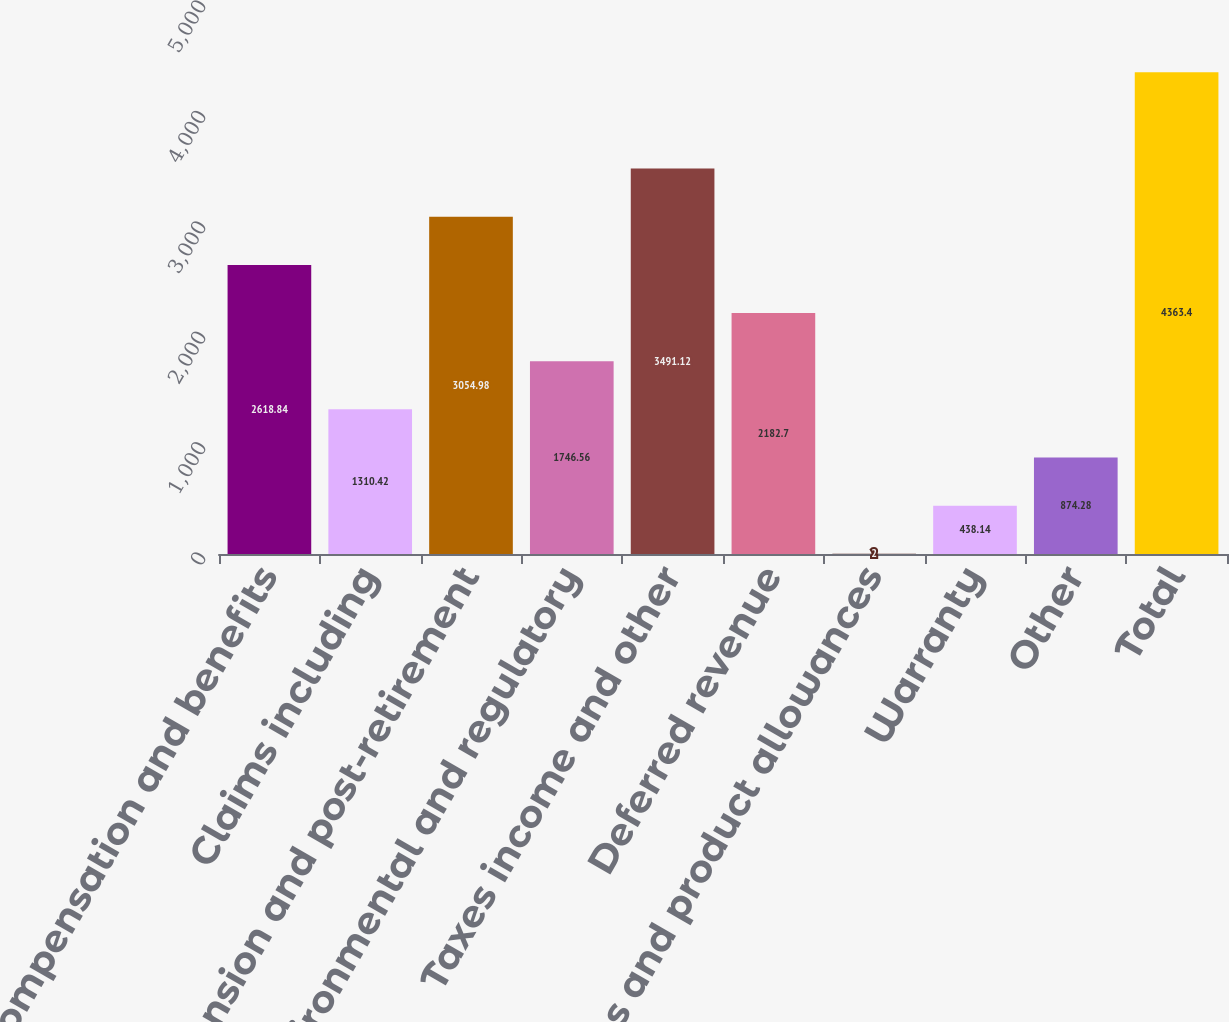Convert chart. <chart><loc_0><loc_0><loc_500><loc_500><bar_chart><fcel>Compensation and benefits<fcel>Claims including<fcel>Pension and post-retirement<fcel>Environmental and regulatory<fcel>Taxes income and other<fcel>Deferred revenue<fcel>Sales and product allowances<fcel>Warranty<fcel>Other<fcel>Total<nl><fcel>2618.84<fcel>1310.42<fcel>3054.98<fcel>1746.56<fcel>3491.12<fcel>2182.7<fcel>2<fcel>438.14<fcel>874.28<fcel>4363.4<nl></chart> 